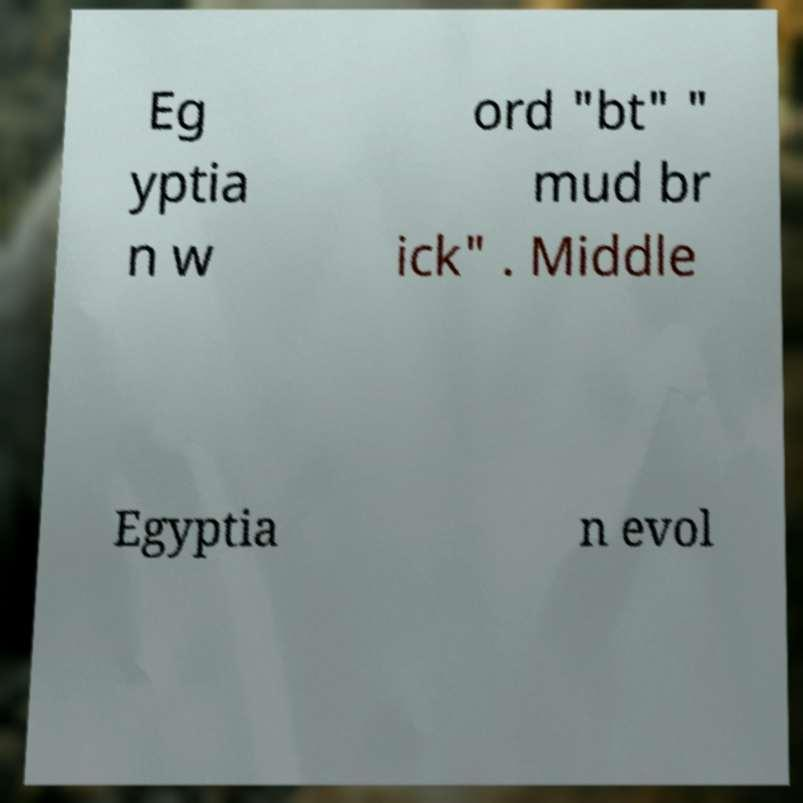Can you accurately transcribe the text from the provided image for me? Eg yptia n w ord "bt" " mud br ick" . Middle Egyptia n evol 